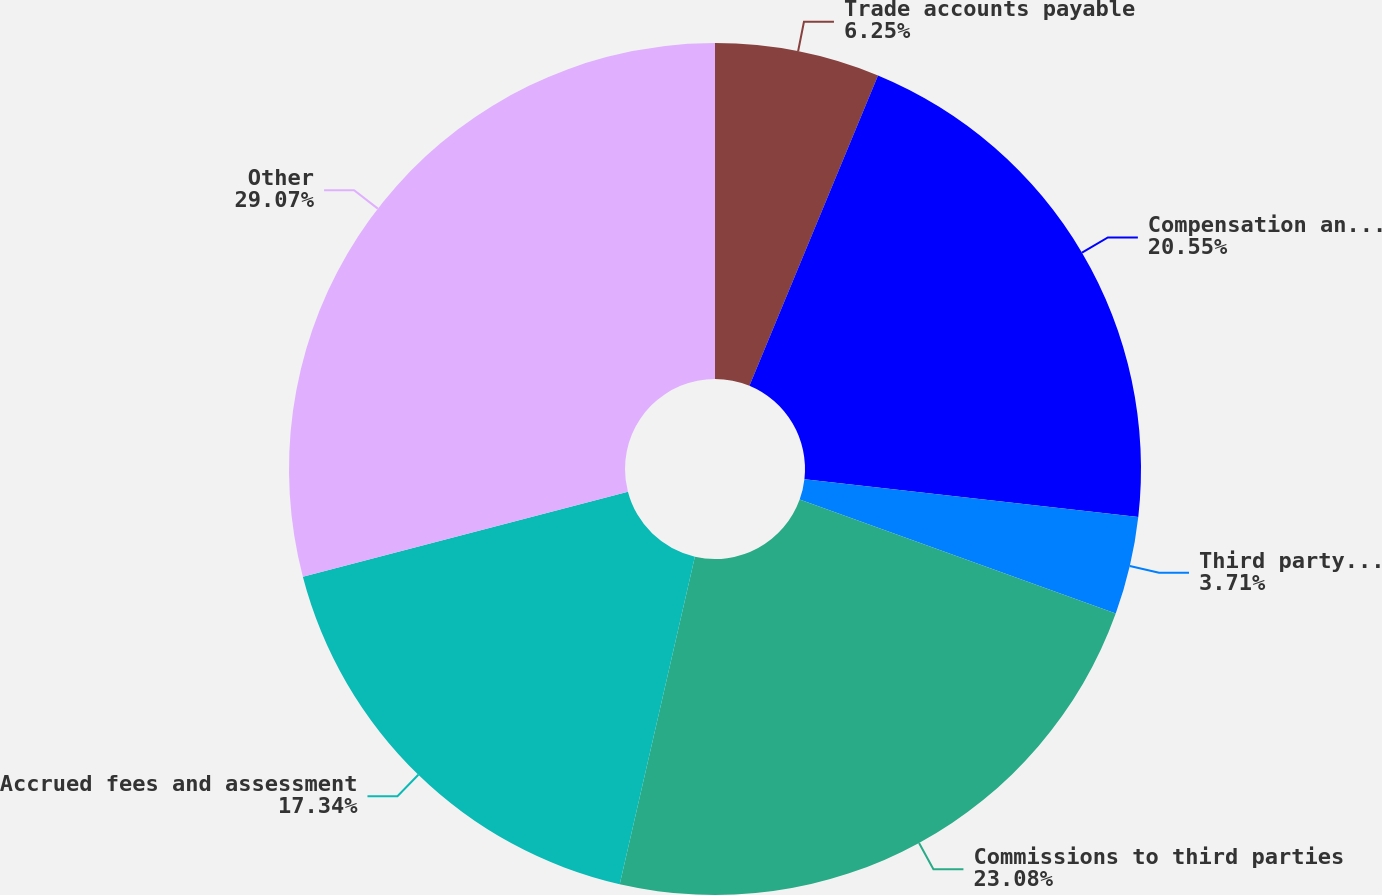Convert chart. <chart><loc_0><loc_0><loc_500><loc_500><pie_chart><fcel>Trade accounts payable<fcel>Compensation and benefits<fcel>Third party processing<fcel>Commissions to third parties<fcel>Accrued fees and assessment<fcel>Other<nl><fcel>6.25%<fcel>20.55%<fcel>3.71%<fcel>23.08%<fcel>17.34%<fcel>29.07%<nl></chart> 